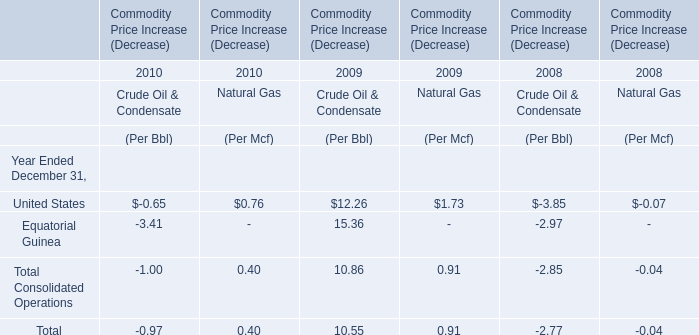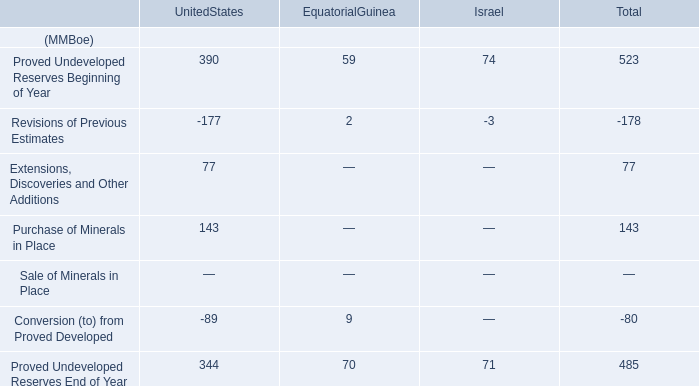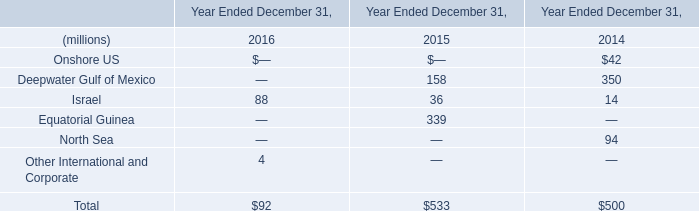What is the Commodity Price Increase (Decrease) of Crude Oil & Condensate totally in 2010? 
Answer: -0.97. Which year is the Commodity Price Increase of Natural Gas totally larger? 
Answer: 2009. 